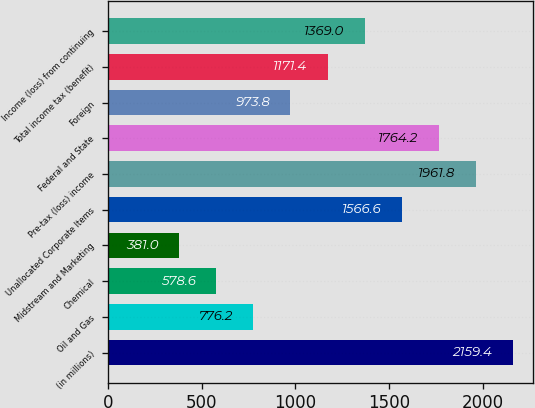Convert chart to OTSL. <chart><loc_0><loc_0><loc_500><loc_500><bar_chart><fcel>(in millions)<fcel>Oil and Gas<fcel>Chemical<fcel>Midstream and Marketing<fcel>Unallocated Corporate Items<fcel>Pre-tax (loss) income<fcel>Federal and State<fcel>Foreign<fcel>Total income tax (benefit)<fcel>Income (loss) from continuing<nl><fcel>2159.4<fcel>776.2<fcel>578.6<fcel>381<fcel>1566.6<fcel>1961.8<fcel>1764.2<fcel>973.8<fcel>1171.4<fcel>1369<nl></chart> 